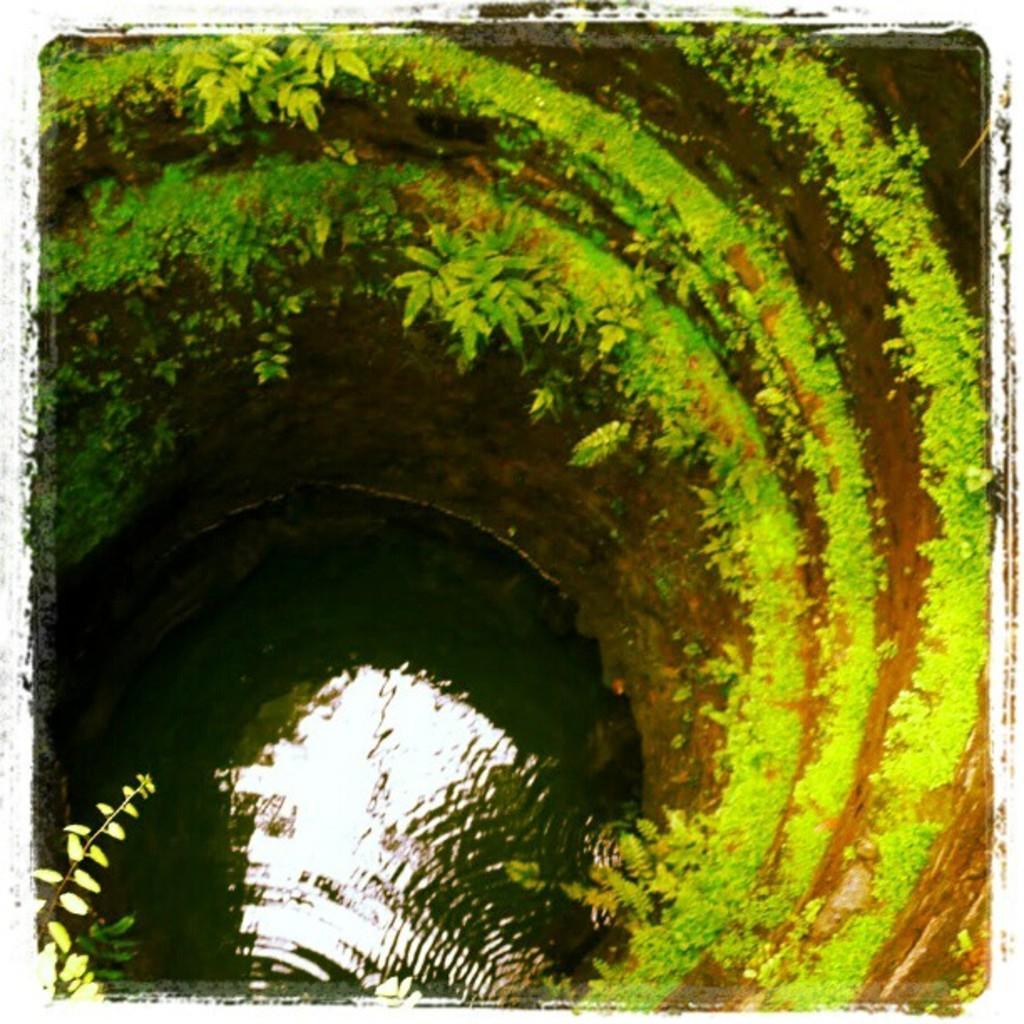Describe this image in one or two sentences. This is the image of a well where we can see greenery on the wall and the water at the bottom. 